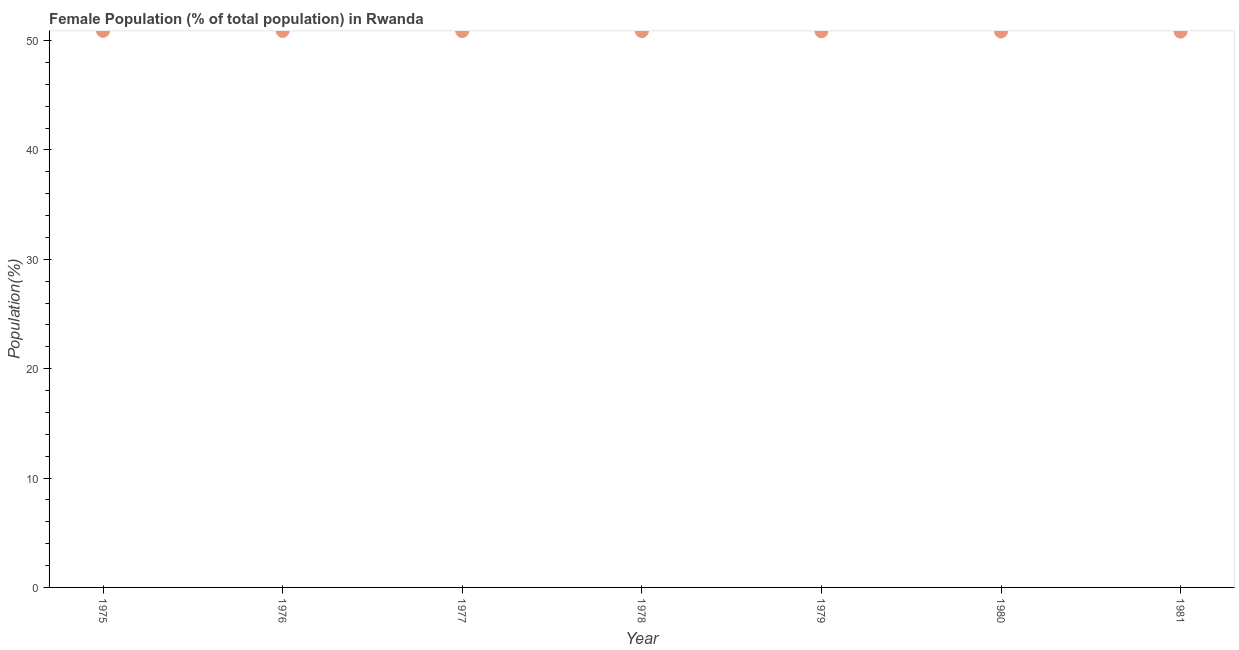What is the female population in 1975?
Offer a very short reply. 50.89. Across all years, what is the maximum female population?
Your response must be concise. 50.89. Across all years, what is the minimum female population?
Offer a terse response. 50.82. In which year was the female population maximum?
Offer a very short reply. 1975. In which year was the female population minimum?
Offer a terse response. 1981. What is the sum of the female population?
Offer a very short reply. 356.01. What is the difference between the female population in 1975 and 1979?
Offer a very short reply. 0.04. What is the average female population per year?
Ensure brevity in your answer.  50.86. What is the median female population?
Give a very brief answer. 50.86. What is the ratio of the female population in 1975 to that in 1978?
Offer a very short reply. 1. Is the difference between the female population in 1975 and 1980 greater than the difference between any two years?
Provide a succinct answer. No. What is the difference between the highest and the second highest female population?
Ensure brevity in your answer.  0.01. What is the difference between the highest and the lowest female population?
Give a very brief answer. 0.07. How many dotlines are there?
Provide a short and direct response. 1. Are the values on the major ticks of Y-axis written in scientific E-notation?
Your answer should be compact. No. What is the title of the graph?
Offer a very short reply. Female Population (% of total population) in Rwanda. What is the label or title of the X-axis?
Keep it short and to the point. Year. What is the label or title of the Y-axis?
Your response must be concise. Population(%). What is the Population(%) in 1975?
Provide a short and direct response. 50.89. What is the Population(%) in 1976?
Offer a very short reply. 50.88. What is the Population(%) in 1977?
Make the answer very short. 50.87. What is the Population(%) in 1978?
Provide a short and direct response. 50.86. What is the Population(%) in 1979?
Give a very brief answer. 50.85. What is the Population(%) in 1980?
Make the answer very short. 50.83. What is the Population(%) in 1981?
Provide a succinct answer. 50.82. What is the difference between the Population(%) in 1975 and 1976?
Provide a short and direct response. 0.01. What is the difference between the Population(%) in 1975 and 1977?
Offer a very short reply. 0.02. What is the difference between the Population(%) in 1975 and 1978?
Provide a short and direct response. 0.03. What is the difference between the Population(%) in 1975 and 1979?
Offer a terse response. 0.04. What is the difference between the Population(%) in 1975 and 1980?
Offer a terse response. 0.06. What is the difference between the Population(%) in 1975 and 1981?
Keep it short and to the point. 0.07. What is the difference between the Population(%) in 1976 and 1977?
Provide a short and direct response. 0.01. What is the difference between the Population(%) in 1976 and 1978?
Ensure brevity in your answer.  0.02. What is the difference between the Population(%) in 1976 and 1979?
Provide a short and direct response. 0.03. What is the difference between the Population(%) in 1976 and 1980?
Provide a short and direct response. 0.05. What is the difference between the Population(%) in 1976 and 1981?
Offer a very short reply. 0.06. What is the difference between the Population(%) in 1977 and 1978?
Provide a short and direct response. 0.01. What is the difference between the Population(%) in 1977 and 1979?
Provide a succinct answer. 0.02. What is the difference between the Population(%) in 1977 and 1980?
Your answer should be very brief. 0.04. What is the difference between the Population(%) in 1977 and 1981?
Your response must be concise. 0.05. What is the difference between the Population(%) in 1978 and 1979?
Your answer should be very brief. 0.01. What is the difference between the Population(%) in 1978 and 1980?
Provide a short and direct response. 0.03. What is the difference between the Population(%) in 1978 and 1981?
Keep it short and to the point. 0.04. What is the difference between the Population(%) in 1979 and 1980?
Ensure brevity in your answer.  0.01. What is the difference between the Population(%) in 1979 and 1981?
Offer a terse response. 0.03. What is the difference between the Population(%) in 1980 and 1981?
Provide a succinct answer. 0.01. What is the ratio of the Population(%) in 1975 to that in 1977?
Offer a terse response. 1. What is the ratio of the Population(%) in 1975 to that in 1978?
Your answer should be compact. 1. What is the ratio of the Population(%) in 1975 to that in 1979?
Your answer should be very brief. 1. What is the ratio of the Population(%) in 1976 to that in 1979?
Your answer should be very brief. 1. What is the ratio of the Population(%) in 1976 to that in 1980?
Your response must be concise. 1. What is the ratio of the Population(%) in 1977 to that in 1981?
Provide a short and direct response. 1. What is the ratio of the Population(%) in 1978 to that in 1979?
Make the answer very short. 1. What is the ratio of the Population(%) in 1978 to that in 1981?
Make the answer very short. 1. What is the ratio of the Population(%) in 1979 to that in 1980?
Offer a very short reply. 1. 